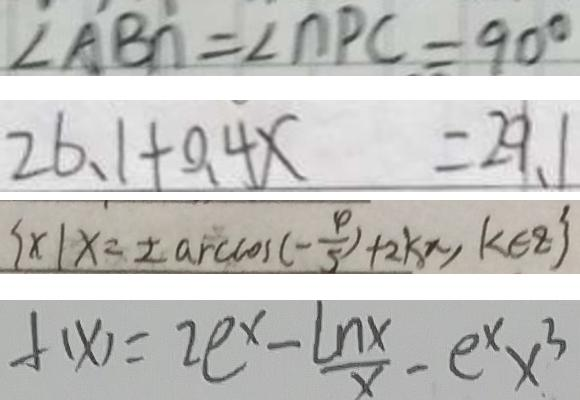Convert formula to latex. <formula><loc_0><loc_0><loc_500><loc_500>\angle A B n = \angle n P C = 9 0 ^ { \circ } 
 2 6 、 1 + 0 . 4 x = 2 9 . 1 
 \{ x \vert x = \pm \arccos ( - \frac { 4 } { 5 } ) + 2 k \pi , k \in z \} 
 f ( x ) = 2 e ^ { x } - \frac { \ln x } { x } - e ^ { x } x ^ { 3 }</formula> 